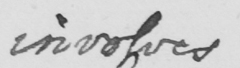Can you read and transcribe this handwriting? involves 